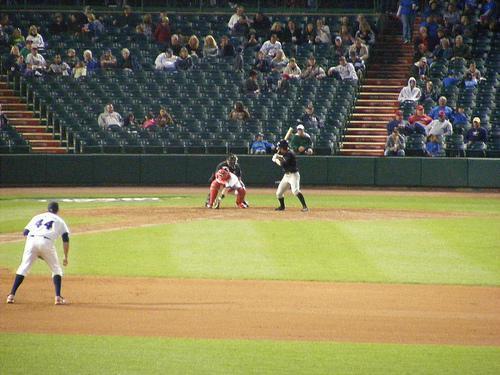How many players are on the field?
Give a very brief answer. 4. 